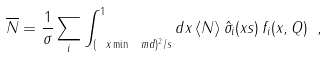<formula> <loc_0><loc_0><loc_500><loc_500>\overline { N } = \frac { 1 } { \sigma } \sum _ { i } \int _ { ( \ x \min \ m d ) ^ { 2 } / s } ^ { 1 } d x \, \langle N \rangle \, \hat { \sigma } _ { i } ( x s ) \, f _ { i } ( x , Q ) \ ,</formula> 